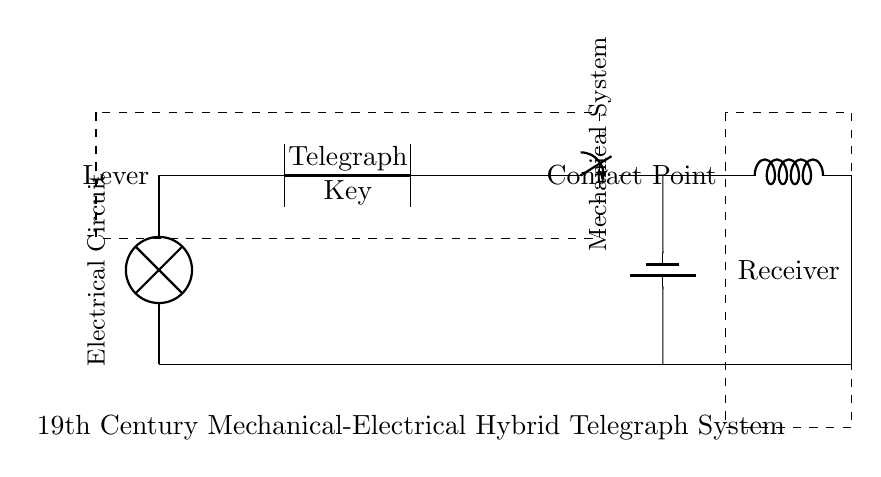What is the mechanical component in the circuit? The lever is the mechanical component in the circuit, as it is clearly labeled and depicted on the left side of the diagram.
Answer: Lever What connects to the contact point? The contact point connects to the electrical switch, which is represented by a solid line extending from the contact point.
Answer: Switch What is the function of the inductor in this circuit? The inductor functions as part of the receiver section of the circuit, which typically involves filtering or energy storage in the context of a telegraph system.
Answer: Filtering How many components are in the electrical system? The electrical system includes four distinct components: a switch, a battery, a lamp, and an inductor, as illustrated in the circuit diagram.
Answer: Four What type of circuit is represented? The circuit is a hybrid system, integrating mechanical components with electrical elements, specifically a telegraph system from the 19th century.
Answer: Hybrid What is the purpose of the telegraph key? The telegraph key serves to make and break the electrical circuit, thus allowing the user to send Morse code by controlling the flow of electricity.
Answer: Send Morse code How does the mechanical lever interact with the electrical system? The mechanical lever controls the contact points that connect and disconnect the electrical switch, thereby influencing the flow of current in the circuit.
Answer: Controls current flow 